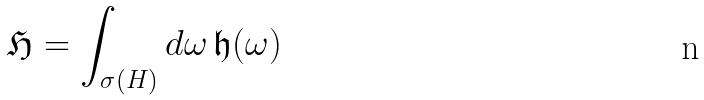Convert formula to latex. <formula><loc_0><loc_0><loc_500><loc_500>\mathfrak { H } = \int _ { \sigma ( H ) } d \omega \, \mathfrak { h } ( \omega )</formula> 